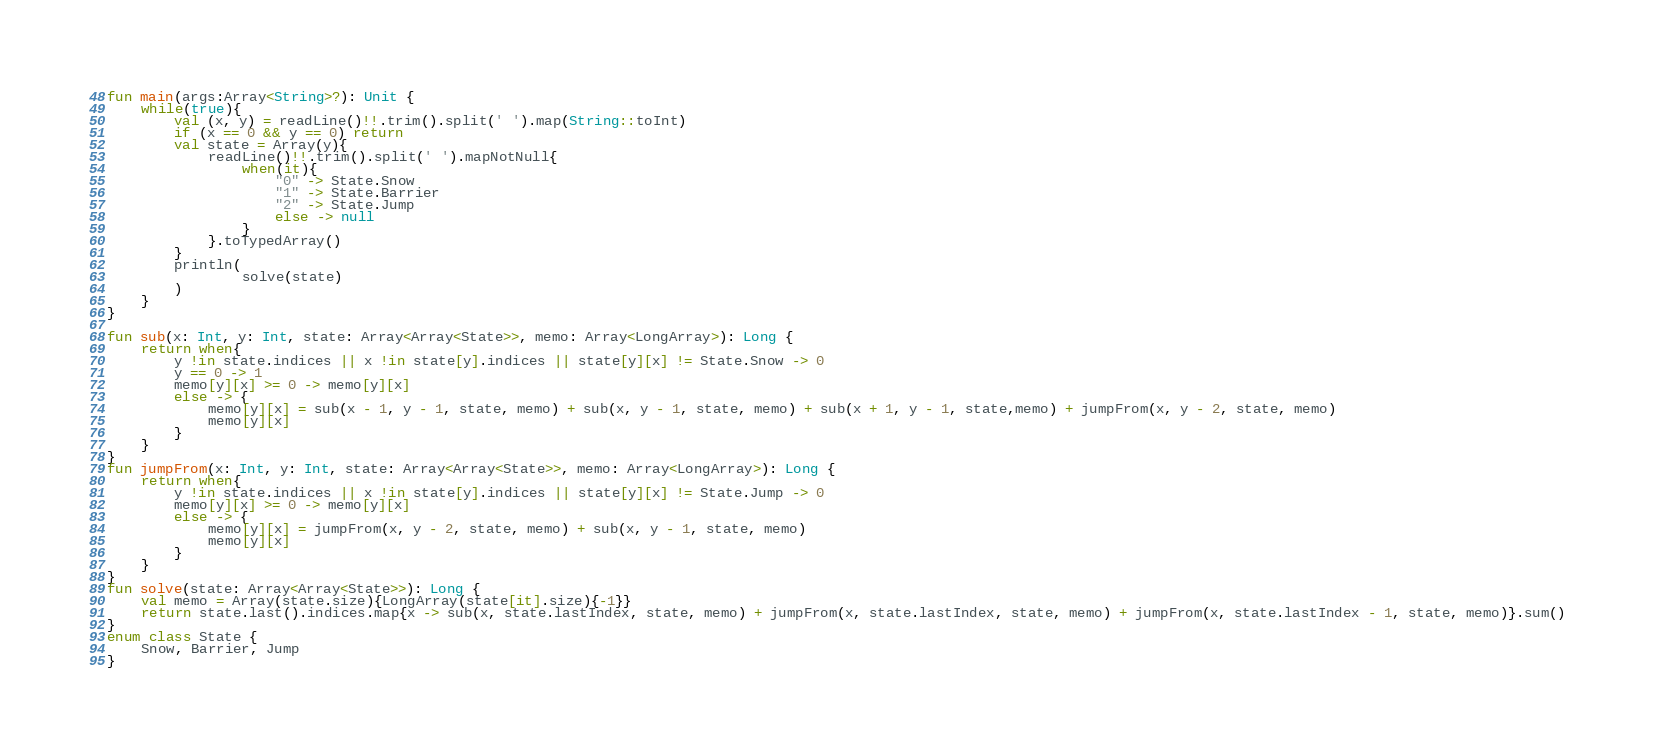<code> <loc_0><loc_0><loc_500><loc_500><_Kotlin_>fun main(args:Array<String>?): Unit {
    while(true){
        val (x, y) = readLine()!!.trim().split(' ').map(String::toInt)
        if (x == 0 && y == 0) return
        val state = Array(y){
            readLine()!!.trim().split(' ').mapNotNull{
                when(it){
                    "0" -> State.Snow
                    "1" -> State.Barrier
                    "2" -> State.Jump
                    else -> null
                }
            }.toTypedArray()
        }
        println(
                solve(state)
        )
    }
}

fun sub(x: Int, y: Int, state: Array<Array<State>>, memo: Array<LongArray>): Long {
    return when{
        y !in state.indices || x !in state[y].indices || state[y][x] != State.Snow -> 0
        y == 0 -> 1
        memo[y][x] >= 0 -> memo[y][x]
        else -> {
            memo[y][x] = sub(x - 1, y - 1, state, memo) + sub(x, y - 1, state, memo) + sub(x + 1, y - 1, state,memo) + jumpFrom(x, y - 2, state, memo)
            memo[y][x]
        }
    }
}
fun jumpFrom(x: Int, y: Int, state: Array<Array<State>>, memo: Array<LongArray>): Long {
    return when{
        y !in state.indices || x !in state[y].indices || state[y][x] != State.Jump -> 0
        memo[y][x] >= 0 -> memo[y][x]
        else -> {
            memo[y][x] = jumpFrom(x, y - 2, state, memo) + sub(x, y - 1, state, memo)
            memo[y][x]
        }
    }
}
fun solve(state: Array<Array<State>>): Long {
    val memo = Array(state.size){LongArray(state[it].size){-1}}
    return state.last().indices.map{x -> sub(x, state.lastIndex, state, memo) + jumpFrom(x, state.lastIndex, state, memo) + jumpFrom(x, state.lastIndex - 1, state, memo)}.sum()
}
enum class State {
    Snow, Barrier, Jump
}
</code> 